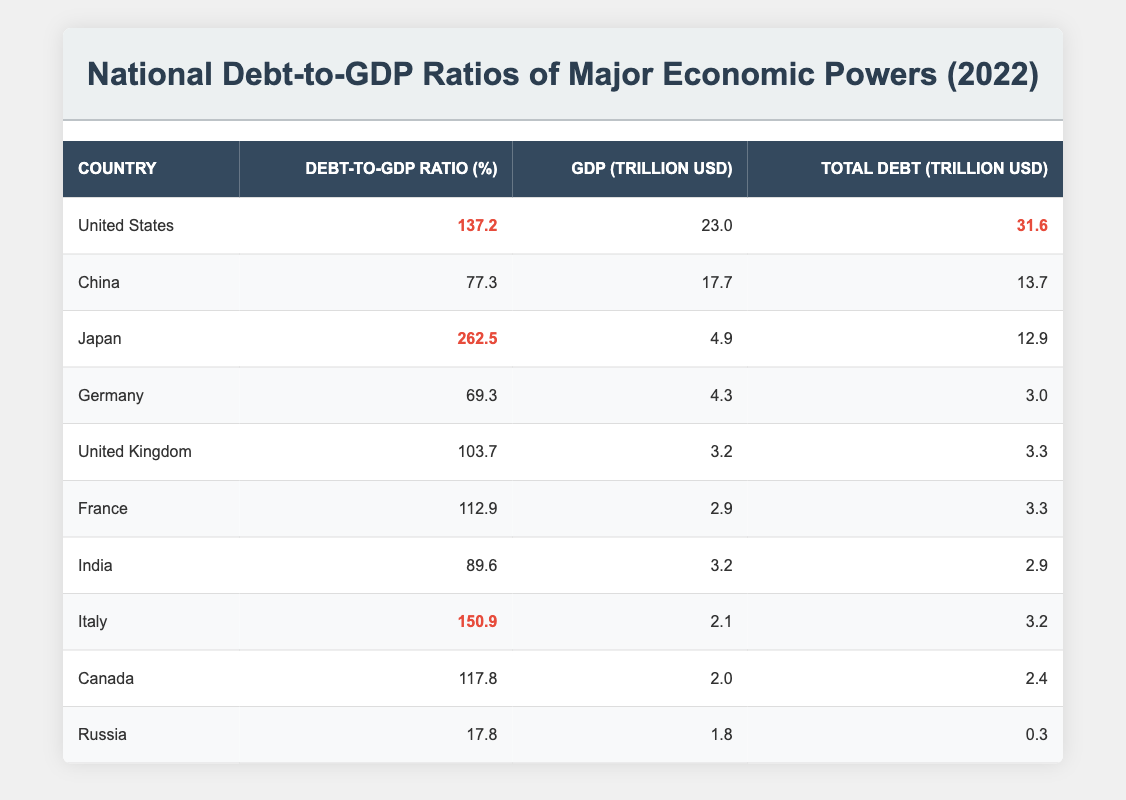What is the Debt-to-GDP Ratio of Japan? From the table, Japan is listed with a Debt-to-GDP Ratio of 262.5%
Answer: 262.5% Which country has the highest total debt in trillions of USD? By examining the "Total Debt" column, the United States shows a total debt of 31.6 trillion USD, which is higher than the totals of all other countries
Answer: 31.6 trillion USD What is the average Debt-to-GDP Ratio of the countries listed? To find the average, I add the Debt-to-GDP Ratios of all countries: (137.2 + 77.3 + 262.5 + 69.3 + 103.7 + 112.9 + 89.6 + 150.9 + 117.8 + 17.8) = 1,190.0. Then I divide by the total number of countries, which is 10. So, 1,190.0 / 10 = 119.0
Answer: 119.0% Is Germany's debt-to-GDP ratio higher than Italy's? From the table, Germany's Debt-to-GDP Ratio is 69.3%, while Italy's is 150.9%. Since 69.3% is less than 150.9%, the statement is false
Answer: No If we compare China to India based on their Debt-to-GDP Ratios, which country has a higher ratio and by how much? China has a Debt-to-GDP Ratio of 77.3% and India has 89.6%. To find the difference: 89.6 - 77.3 = 12.3. Thus, India has a higher ratio than China by 12.3%
Answer: India is higher by 12.3% What is the total GDP of the countries with Debt-to-GDP Ratios above 100%? The countries with Ratios above 100% are the United States (23.0) with 137.2%, Japan (4.9) with 262.5%, the United Kingdom (3.2) with 103.7%, France (2.9) with 112.9%, Italy (2.1) with 150.9%, and Canada (2.0) with 117.8%. Adding these GDPs: 23.0 + 4.9 + 3.2 + 2.9 + 2.1 + 2.0 = 38.1 trillion USD
Answer: 38.1 trillion USD 